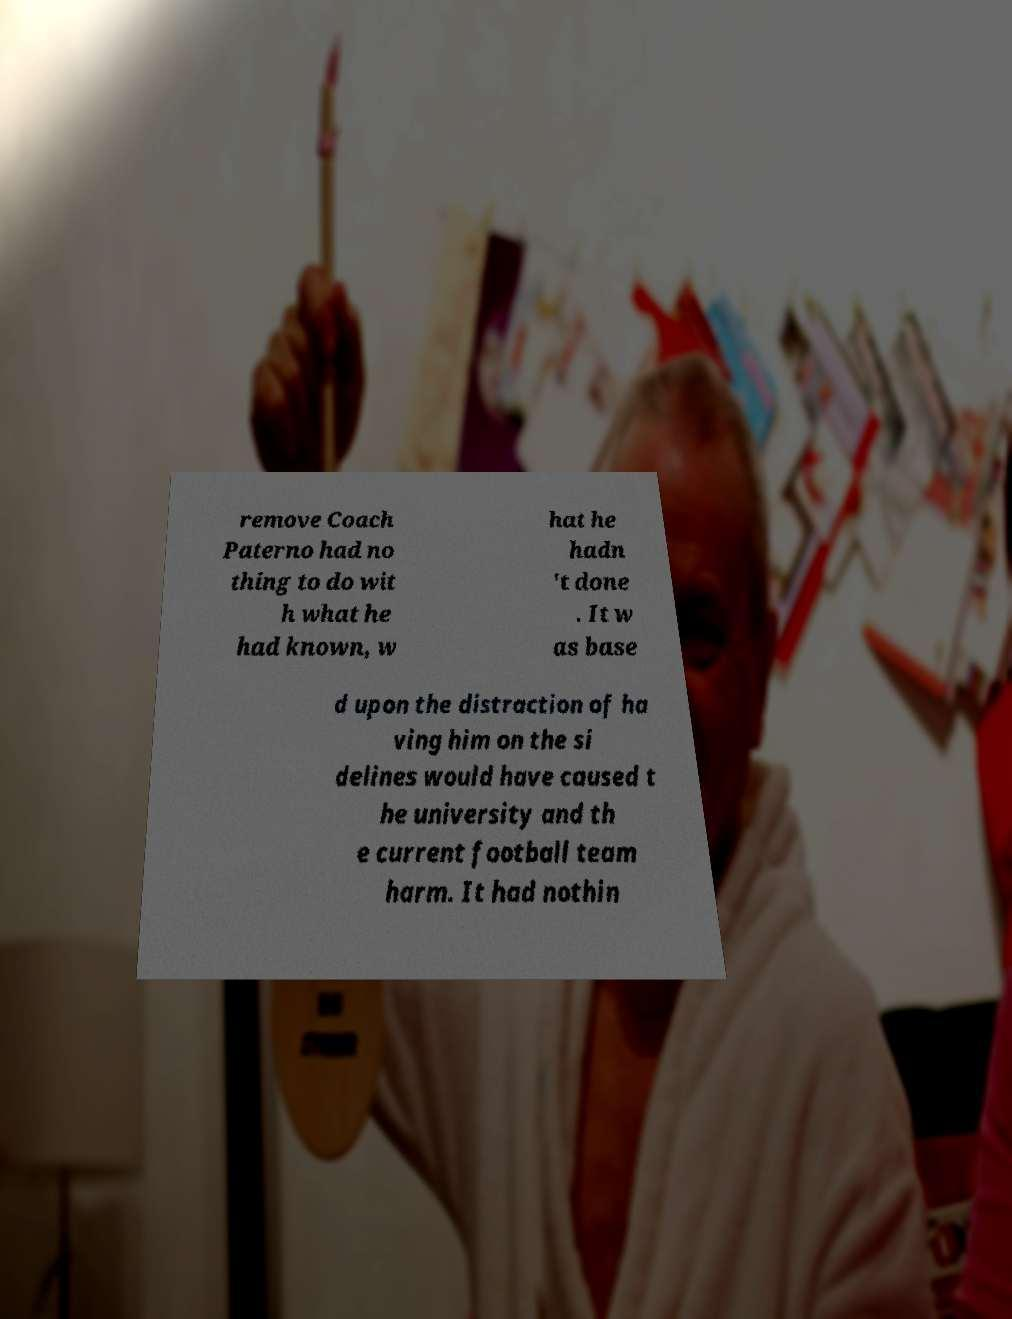I need the written content from this picture converted into text. Can you do that? remove Coach Paterno had no thing to do wit h what he had known, w hat he hadn 't done . It w as base d upon the distraction of ha ving him on the si delines would have caused t he university and th e current football team harm. It had nothin 